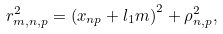<formula> <loc_0><loc_0><loc_500><loc_500>r _ { m , n , p } ^ { 2 } = \left ( x _ { n p } + l _ { 1 } m \right ) ^ { 2 } + \rho _ { n , p } ^ { 2 } ,</formula> 